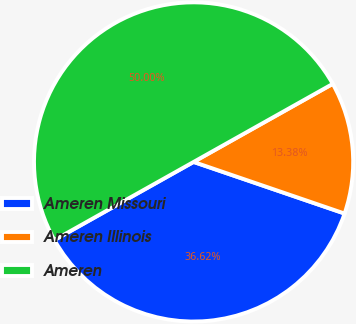Convert chart to OTSL. <chart><loc_0><loc_0><loc_500><loc_500><pie_chart><fcel>Ameren Missouri<fcel>Ameren Illinois<fcel>Ameren<nl><fcel>36.62%<fcel>13.38%<fcel>50.0%<nl></chart> 